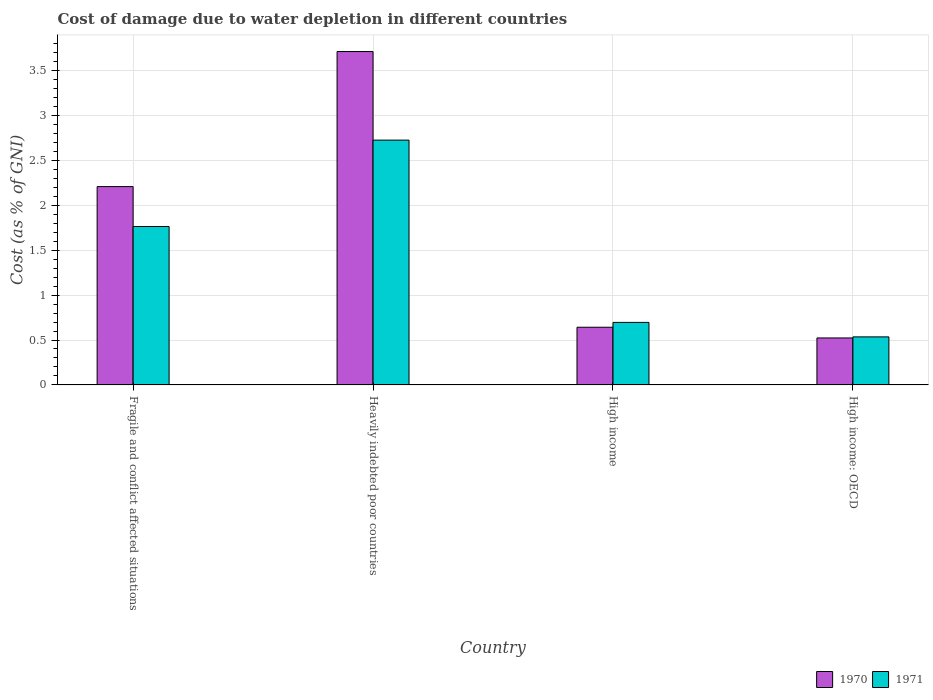How many groups of bars are there?
Your response must be concise. 4. Are the number of bars per tick equal to the number of legend labels?
Keep it short and to the point. Yes. What is the label of the 1st group of bars from the left?
Your response must be concise. Fragile and conflict affected situations. In how many cases, is the number of bars for a given country not equal to the number of legend labels?
Give a very brief answer. 0. What is the cost of damage caused due to water depletion in 1971 in High income: OECD?
Make the answer very short. 0.53. Across all countries, what is the maximum cost of damage caused due to water depletion in 1971?
Make the answer very short. 2.73. Across all countries, what is the minimum cost of damage caused due to water depletion in 1970?
Your answer should be very brief. 0.52. In which country was the cost of damage caused due to water depletion in 1971 maximum?
Your answer should be compact. Heavily indebted poor countries. In which country was the cost of damage caused due to water depletion in 1970 minimum?
Keep it short and to the point. High income: OECD. What is the total cost of damage caused due to water depletion in 1971 in the graph?
Make the answer very short. 5.72. What is the difference between the cost of damage caused due to water depletion in 1970 in Fragile and conflict affected situations and that in Heavily indebted poor countries?
Your answer should be very brief. -1.5. What is the difference between the cost of damage caused due to water depletion in 1970 in Fragile and conflict affected situations and the cost of damage caused due to water depletion in 1971 in High income: OECD?
Provide a short and direct response. 1.67. What is the average cost of damage caused due to water depletion in 1971 per country?
Make the answer very short. 1.43. What is the difference between the cost of damage caused due to water depletion of/in 1971 and cost of damage caused due to water depletion of/in 1970 in High income: OECD?
Offer a very short reply. 0.01. What is the ratio of the cost of damage caused due to water depletion in 1971 in High income to that in High income: OECD?
Provide a short and direct response. 1.3. Is the cost of damage caused due to water depletion in 1970 in Fragile and conflict affected situations less than that in High income: OECD?
Offer a very short reply. No. Is the difference between the cost of damage caused due to water depletion in 1971 in Fragile and conflict affected situations and Heavily indebted poor countries greater than the difference between the cost of damage caused due to water depletion in 1970 in Fragile and conflict affected situations and Heavily indebted poor countries?
Make the answer very short. Yes. What is the difference between the highest and the second highest cost of damage caused due to water depletion in 1970?
Offer a very short reply. -1.57. What is the difference between the highest and the lowest cost of damage caused due to water depletion in 1970?
Your answer should be compact. 3.19. In how many countries, is the cost of damage caused due to water depletion in 1971 greater than the average cost of damage caused due to water depletion in 1971 taken over all countries?
Ensure brevity in your answer.  2. Is the sum of the cost of damage caused due to water depletion in 1971 in High income and High income: OECD greater than the maximum cost of damage caused due to water depletion in 1970 across all countries?
Offer a terse response. No. What does the 2nd bar from the left in Heavily indebted poor countries represents?
Your answer should be very brief. 1971. How many countries are there in the graph?
Provide a short and direct response. 4. What is the difference between two consecutive major ticks on the Y-axis?
Give a very brief answer. 0.5. Does the graph contain any zero values?
Your answer should be compact. No. Where does the legend appear in the graph?
Make the answer very short. Bottom right. How many legend labels are there?
Your answer should be very brief. 2. How are the legend labels stacked?
Ensure brevity in your answer.  Horizontal. What is the title of the graph?
Give a very brief answer. Cost of damage due to water depletion in different countries. Does "1976" appear as one of the legend labels in the graph?
Provide a succinct answer. No. What is the label or title of the Y-axis?
Your answer should be compact. Cost (as % of GNI). What is the Cost (as % of GNI) in 1970 in Fragile and conflict affected situations?
Ensure brevity in your answer.  2.21. What is the Cost (as % of GNI) of 1971 in Fragile and conflict affected situations?
Ensure brevity in your answer.  1.76. What is the Cost (as % of GNI) of 1970 in Heavily indebted poor countries?
Keep it short and to the point. 3.71. What is the Cost (as % of GNI) of 1971 in Heavily indebted poor countries?
Ensure brevity in your answer.  2.73. What is the Cost (as % of GNI) in 1970 in High income?
Provide a short and direct response. 0.64. What is the Cost (as % of GNI) of 1971 in High income?
Provide a succinct answer. 0.7. What is the Cost (as % of GNI) of 1970 in High income: OECD?
Make the answer very short. 0.52. What is the Cost (as % of GNI) of 1971 in High income: OECD?
Your answer should be compact. 0.53. Across all countries, what is the maximum Cost (as % of GNI) in 1970?
Offer a terse response. 3.71. Across all countries, what is the maximum Cost (as % of GNI) in 1971?
Offer a very short reply. 2.73. Across all countries, what is the minimum Cost (as % of GNI) in 1970?
Your answer should be very brief. 0.52. Across all countries, what is the minimum Cost (as % of GNI) of 1971?
Offer a terse response. 0.53. What is the total Cost (as % of GNI) in 1970 in the graph?
Give a very brief answer. 7.09. What is the total Cost (as % of GNI) in 1971 in the graph?
Offer a very short reply. 5.72. What is the difference between the Cost (as % of GNI) of 1970 in Fragile and conflict affected situations and that in Heavily indebted poor countries?
Your response must be concise. -1.5. What is the difference between the Cost (as % of GNI) of 1971 in Fragile and conflict affected situations and that in Heavily indebted poor countries?
Your answer should be compact. -0.96. What is the difference between the Cost (as % of GNI) in 1970 in Fragile and conflict affected situations and that in High income?
Offer a very short reply. 1.57. What is the difference between the Cost (as % of GNI) of 1971 in Fragile and conflict affected situations and that in High income?
Your answer should be very brief. 1.07. What is the difference between the Cost (as % of GNI) of 1970 in Fragile and conflict affected situations and that in High income: OECD?
Provide a succinct answer. 1.69. What is the difference between the Cost (as % of GNI) of 1971 in Fragile and conflict affected situations and that in High income: OECD?
Offer a terse response. 1.23. What is the difference between the Cost (as % of GNI) of 1970 in Heavily indebted poor countries and that in High income?
Make the answer very short. 3.07. What is the difference between the Cost (as % of GNI) in 1971 in Heavily indebted poor countries and that in High income?
Offer a very short reply. 2.03. What is the difference between the Cost (as % of GNI) in 1970 in Heavily indebted poor countries and that in High income: OECD?
Make the answer very short. 3.19. What is the difference between the Cost (as % of GNI) of 1971 in Heavily indebted poor countries and that in High income: OECD?
Offer a terse response. 2.19. What is the difference between the Cost (as % of GNI) in 1970 in High income and that in High income: OECD?
Your response must be concise. 0.12. What is the difference between the Cost (as % of GNI) in 1971 in High income and that in High income: OECD?
Ensure brevity in your answer.  0.16. What is the difference between the Cost (as % of GNI) of 1970 in Fragile and conflict affected situations and the Cost (as % of GNI) of 1971 in Heavily indebted poor countries?
Your answer should be very brief. -0.52. What is the difference between the Cost (as % of GNI) in 1970 in Fragile and conflict affected situations and the Cost (as % of GNI) in 1971 in High income?
Provide a short and direct response. 1.51. What is the difference between the Cost (as % of GNI) of 1970 in Fragile and conflict affected situations and the Cost (as % of GNI) of 1971 in High income: OECD?
Your response must be concise. 1.67. What is the difference between the Cost (as % of GNI) in 1970 in Heavily indebted poor countries and the Cost (as % of GNI) in 1971 in High income?
Offer a terse response. 3.02. What is the difference between the Cost (as % of GNI) of 1970 in Heavily indebted poor countries and the Cost (as % of GNI) of 1971 in High income: OECD?
Ensure brevity in your answer.  3.18. What is the difference between the Cost (as % of GNI) in 1970 in High income and the Cost (as % of GNI) in 1971 in High income: OECD?
Offer a very short reply. 0.11. What is the average Cost (as % of GNI) in 1970 per country?
Make the answer very short. 1.77. What is the average Cost (as % of GNI) in 1971 per country?
Ensure brevity in your answer.  1.43. What is the difference between the Cost (as % of GNI) in 1970 and Cost (as % of GNI) in 1971 in Fragile and conflict affected situations?
Your answer should be compact. 0.44. What is the difference between the Cost (as % of GNI) of 1970 and Cost (as % of GNI) of 1971 in Heavily indebted poor countries?
Give a very brief answer. 0.99. What is the difference between the Cost (as % of GNI) in 1970 and Cost (as % of GNI) in 1971 in High income?
Offer a terse response. -0.05. What is the difference between the Cost (as % of GNI) of 1970 and Cost (as % of GNI) of 1971 in High income: OECD?
Give a very brief answer. -0.01. What is the ratio of the Cost (as % of GNI) of 1970 in Fragile and conflict affected situations to that in Heavily indebted poor countries?
Offer a very short reply. 0.59. What is the ratio of the Cost (as % of GNI) in 1971 in Fragile and conflict affected situations to that in Heavily indebted poor countries?
Provide a succinct answer. 0.65. What is the ratio of the Cost (as % of GNI) of 1970 in Fragile and conflict affected situations to that in High income?
Offer a very short reply. 3.44. What is the ratio of the Cost (as % of GNI) in 1971 in Fragile and conflict affected situations to that in High income?
Make the answer very short. 2.53. What is the ratio of the Cost (as % of GNI) of 1970 in Fragile and conflict affected situations to that in High income: OECD?
Ensure brevity in your answer.  4.22. What is the ratio of the Cost (as % of GNI) in 1971 in Fragile and conflict affected situations to that in High income: OECD?
Offer a terse response. 3.3. What is the ratio of the Cost (as % of GNI) of 1970 in Heavily indebted poor countries to that in High income?
Your answer should be compact. 5.78. What is the ratio of the Cost (as % of GNI) in 1971 in Heavily indebted poor countries to that in High income?
Your answer should be very brief. 3.92. What is the ratio of the Cost (as % of GNI) of 1970 in Heavily indebted poor countries to that in High income: OECD?
Ensure brevity in your answer.  7.1. What is the ratio of the Cost (as % of GNI) in 1971 in Heavily indebted poor countries to that in High income: OECD?
Your answer should be compact. 5.1. What is the ratio of the Cost (as % of GNI) of 1970 in High income to that in High income: OECD?
Your answer should be very brief. 1.23. What is the ratio of the Cost (as % of GNI) in 1971 in High income to that in High income: OECD?
Give a very brief answer. 1.3. What is the difference between the highest and the second highest Cost (as % of GNI) in 1970?
Your answer should be compact. 1.5. What is the difference between the highest and the second highest Cost (as % of GNI) of 1971?
Your response must be concise. 0.96. What is the difference between the highest and the lowest Cost (as % of GNI) of 1970?
Offer a very short reply. 3.19. What is the difference between the highest and the lowest Cost (as % of GNI) in 1971?
Provide a short and direct response. 2.19. 